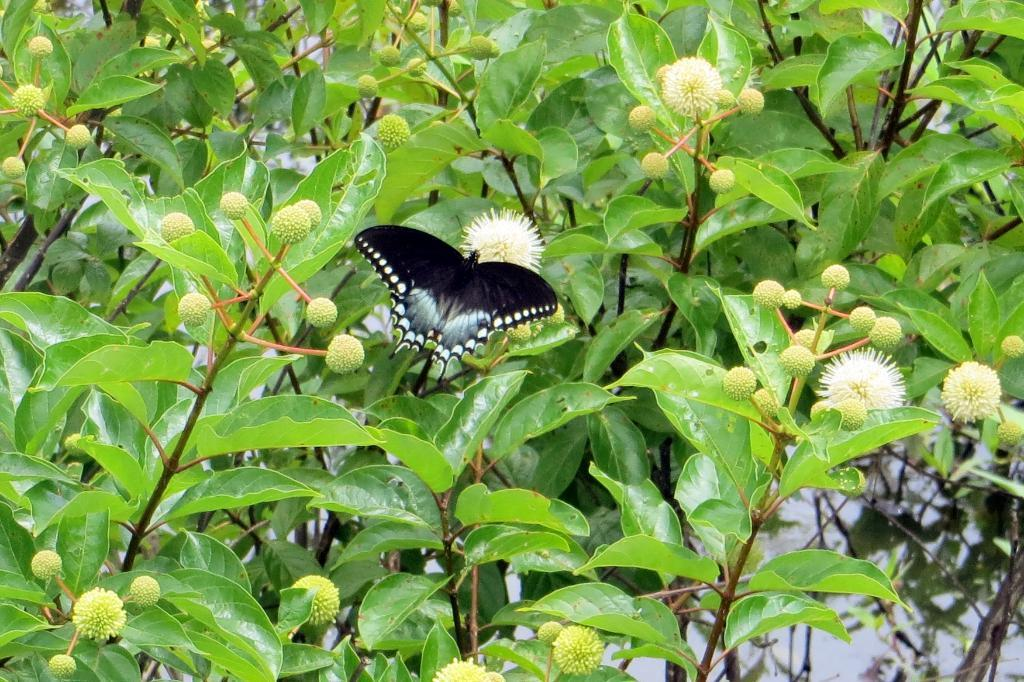What type of living organisms can be seen in the image? Plants and a butterfly are visible in the image. Can you describe the butterfly in the image? The butterfly is a colorful insect with wings. What type of frame is holding the butterfly in the image? There is no frame holding the butterfly in the image; it is flying freely among the plants. 